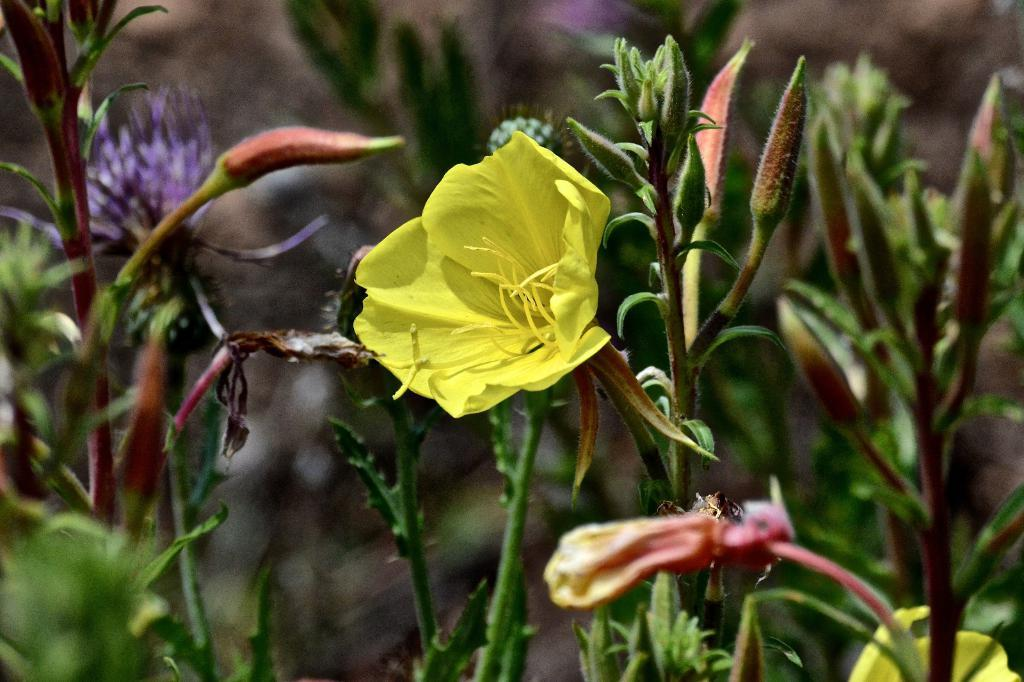What type of living organisms can be seen in the image? Plants and flowers are visible in the image. Can you describe the specific plants or flowers in the image? Unfortunately, the facts provided do not give specific details about the plants or flowers in the image. What might be the purpose of having plants and flowers in the image? The presence of plants and flowers in the image could be for decorative purposes, to create a natural or calming atmosphere, or to represent growth and life. How does the dock look like in the image? There is no dock present in the image; it only contains plants and flowers. What is the reason for the good-bye in the image? There is no good-bye or any indication of a farewell in the image, as it only features plants and flowers. 